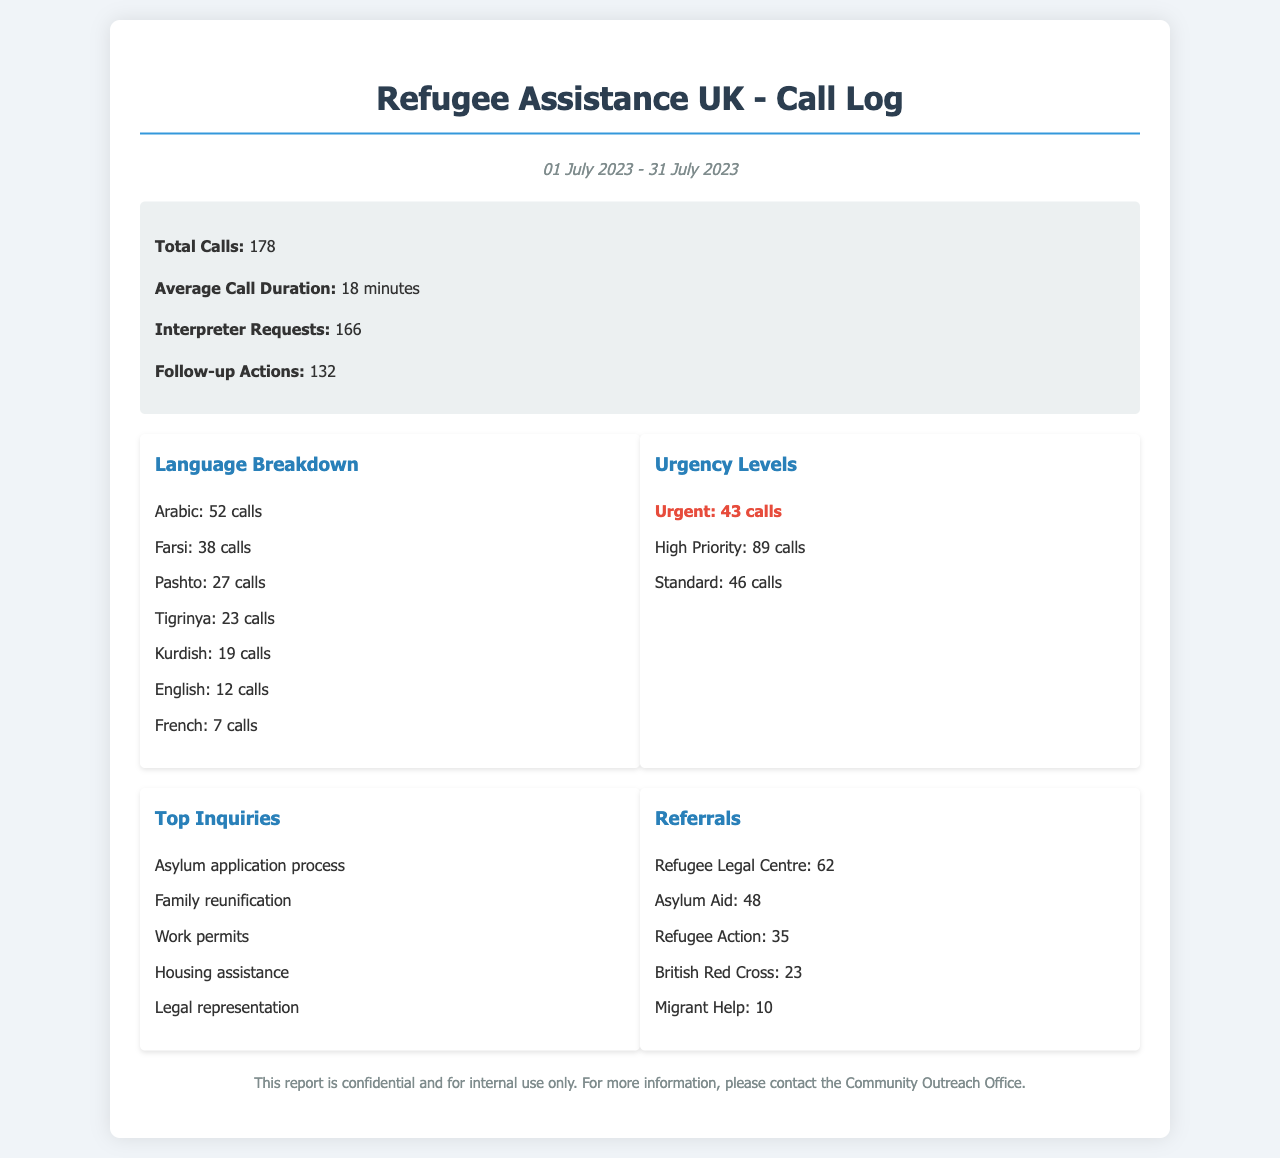What is the total number of calls received? The total number of calls received is detailed in the summary section of the document.
Answer: 178 How many calls were made in Arabic? The document lists the number of calls per language, indicating how many were made in Arabic.
Answer: 52 calls What is the average call duration? The average call duration is specified in the summary section of the document.
Answer: 18 minutes How many urgent calls were there? The urgency levels in the document specify the number of urgent calls separately.
Answer: 43 calls Which organization received the most referrals? The referrals section lists different organizations and the number of referrals they received, identifying which had the highest count.
Answer: Refugee Legal Centre What is the total number of interpreter requests? The summary section of the document provides the total number of interpreter requests made during the reporting period.
Answer: 166 How many inquiries were categorized as high priority? The urgency levels detail how many calls were categorized as high priority.
Answer: 89 calls What language had the least number of calls? The language breakdown indicates the language with the fewest calls.
Answer: French What is one of the top inquiries received? The top inquiries section lists the types of inquiries received during the reporting period.
Answer: Asylum application process How many follow-up actions were noted? The summary section mentions the number of follow-up actions taken based on the calls.
Answer: 132 